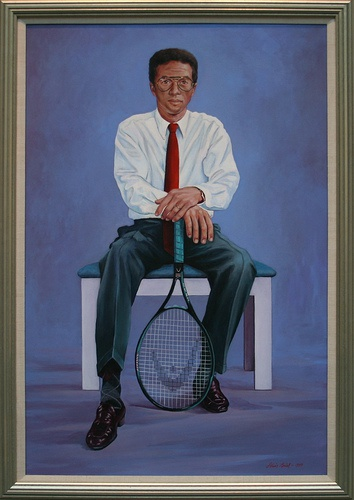Describe the objects in this image and their specific colors. I can see people in gray, black, darkgray, brown, and blue tones, tennis racket in gray, black, and blue tones, bench in gray, darkgray, blue, and black tones, and tie in gray, maroon, and black tones in this image. 